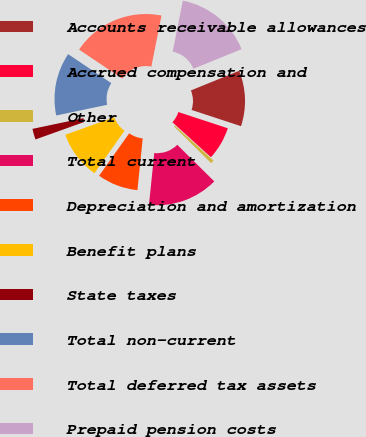Convert chart. <chart><loc_0><loc_0><loc_500><loc_500><pie_chart><fcel>Accounts receivable allowances<fcel>Accrued compensation and<fcel>Other<fcel>Total current<fcel>Depreciation and amortization<fcel>Benefit plans<fcel>State taxes<fcel>Total non-current<fcel>Total deferred tax assets<fcel>Prepaid pension costs<nl><fcel>11.2%<fcel>6.69%<fcel>0.67%<fcel>14.21%<fcel>8.2%<fcel>9.7%<fcel>2.18%<fcel>12.71%<fcel>18.72%<fcel>15.72%<nl></chart> 